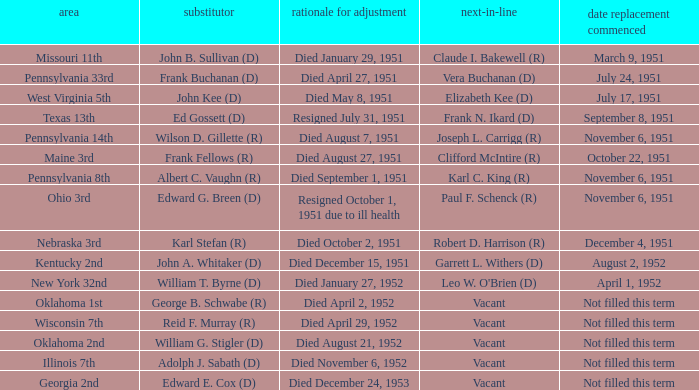Who was the successor for the Kentucky 2nd district? Garrett L. Withers (D). 